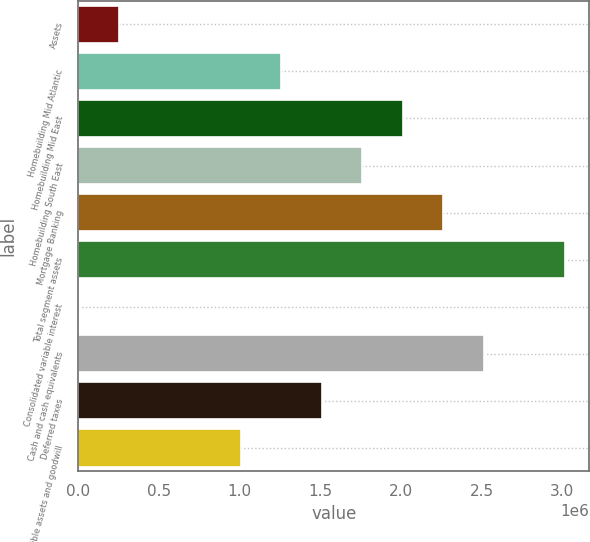Convert chart to OTSL. <chart><loc_0><loc_0><loc_500><loc_500><bar_chart><fcel>Assets<fcel>Homebuilding Mid Atlantic<fcel>Homebuilding Mid East<fcel>Homebuilding South East<fcel>Mortgage Banking<fcel>Total segment assets<fcel>Consolidated variable interest<fcel>Cash and cash equivalents<fcel>Deferred taxes<fcel>Intangible assets and goodwill<nl><fcel>253087<fcel>1.25844e+06<fcel>2.01245e+06<fcel>1.76112e+06<fcel>2.26379e+06<fcel>3.01781e+06<fcel>1749<fcel>2.51513e+06<fcel>1.50978e+06<fcel>1.0071e+06<nl></chart> 